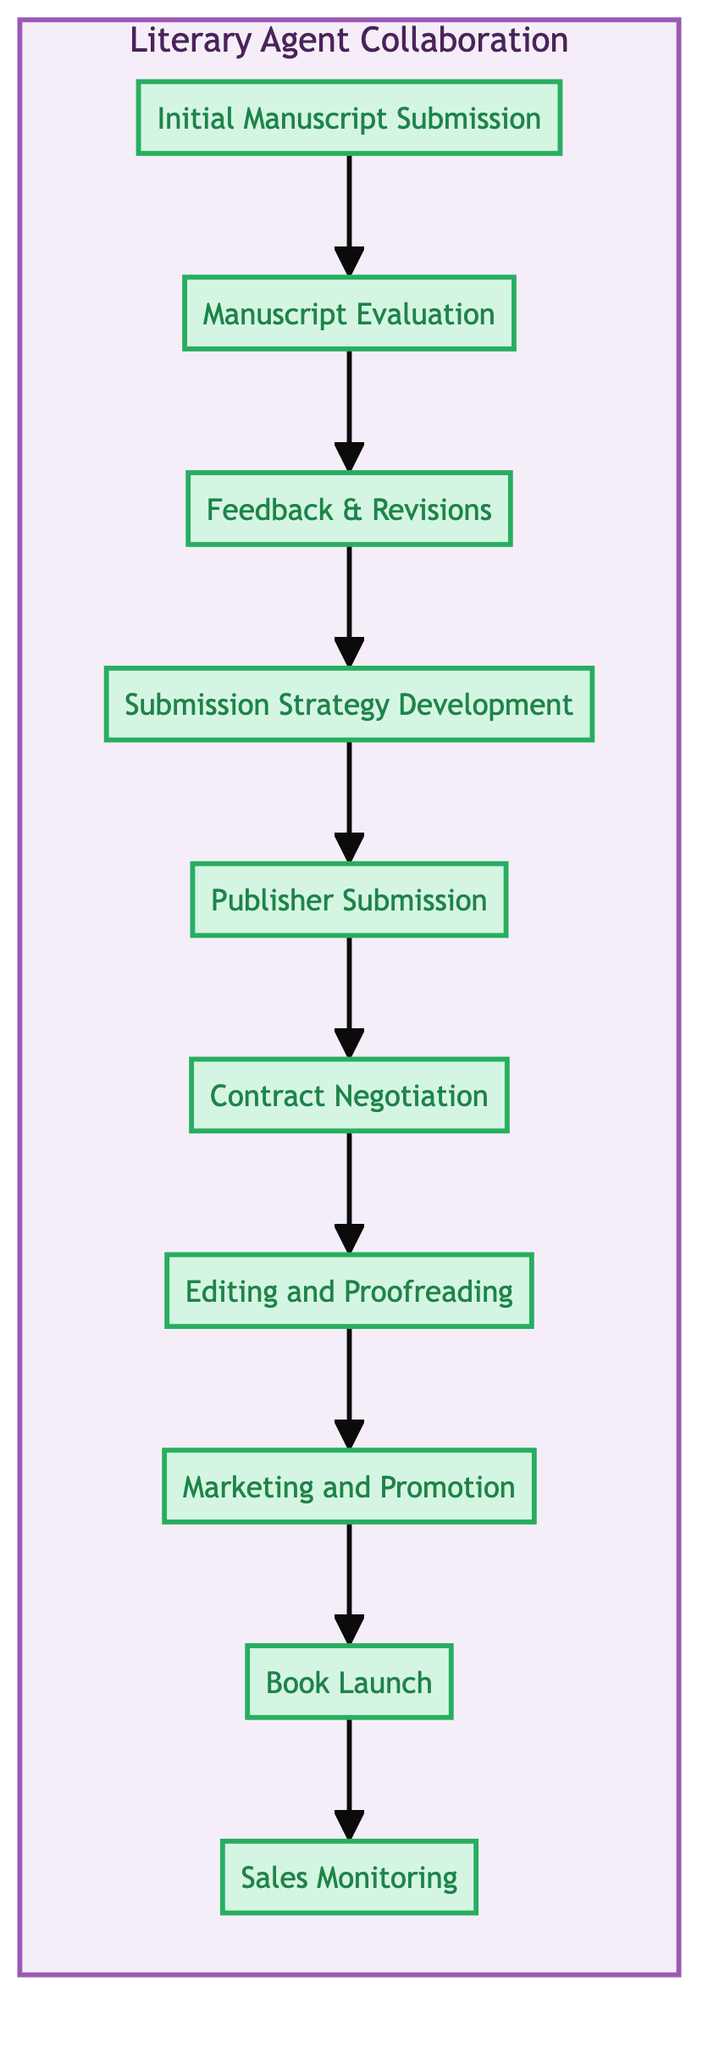What is the first step in the clinical pathway? The diagram indicates that the first step is "Initial Manuscript Submission." This is straightforward as the steps are numbered, and the first step is labeled at the very beginning of the pathway.
Answer: Initial Manuscript Submission How many total steps are in the clinical pathway? By counting the number of steps listed in the diagram, there are a total of ten distinct steps outlined in the clinical pathway.
Answer: 10 What step comes after "Publisher Submission"? Looking at the flow from the "Publisher Submission" node, the next step indicated is "Contract Negotiation," which follows sequentially in the pathway.
Answer: Contract Negotiation Which step involves working with the agent to enhance appeal? The diagram specifies that the "Feedback & Revisions" step is where the author works with the agent to enhance the manuscript’s appeal based on the feedback provided.
Answer: Feedback & Revisions In which step is the book officially released? The diagram clearly identifies the "Book Launch" as the step where the official release of the book takes place, marking a significant moment in the pathway.
Answer: Book Launch What are the last two steps in the clinical pathway? By examining the last few nodes in the diagram, the final two steps are "Book Launch" followed by "Sales Monitoring," indicating the progression towards post-launch activities.
Answer: Book Launch, Sales Monitoring What does the agent do after receiving publisher interest? According to the pathway, after receiving interest from a publisher, the agent engages in "Contract Negotiation" to secure a favorable deal for the author, engaging in critical discussions about terms.
Answer: Contract Negotiation Which step requires collaboration with the publisher’s editorial team? The diagram indicates that the "Editing and Proofreading" step involves collaboration with the publisher’s editorial team to refine the manuscript before publication.
Answer: Editing and Proofreading How does developing a submission strategy help the process? The submission strategy, as indicated later in the pathway, involves collaborative planning with the agent to effectively target suitable publishers, which is crucial for a successful manuscript submission.
Answer: Enhances targeting of publishers 